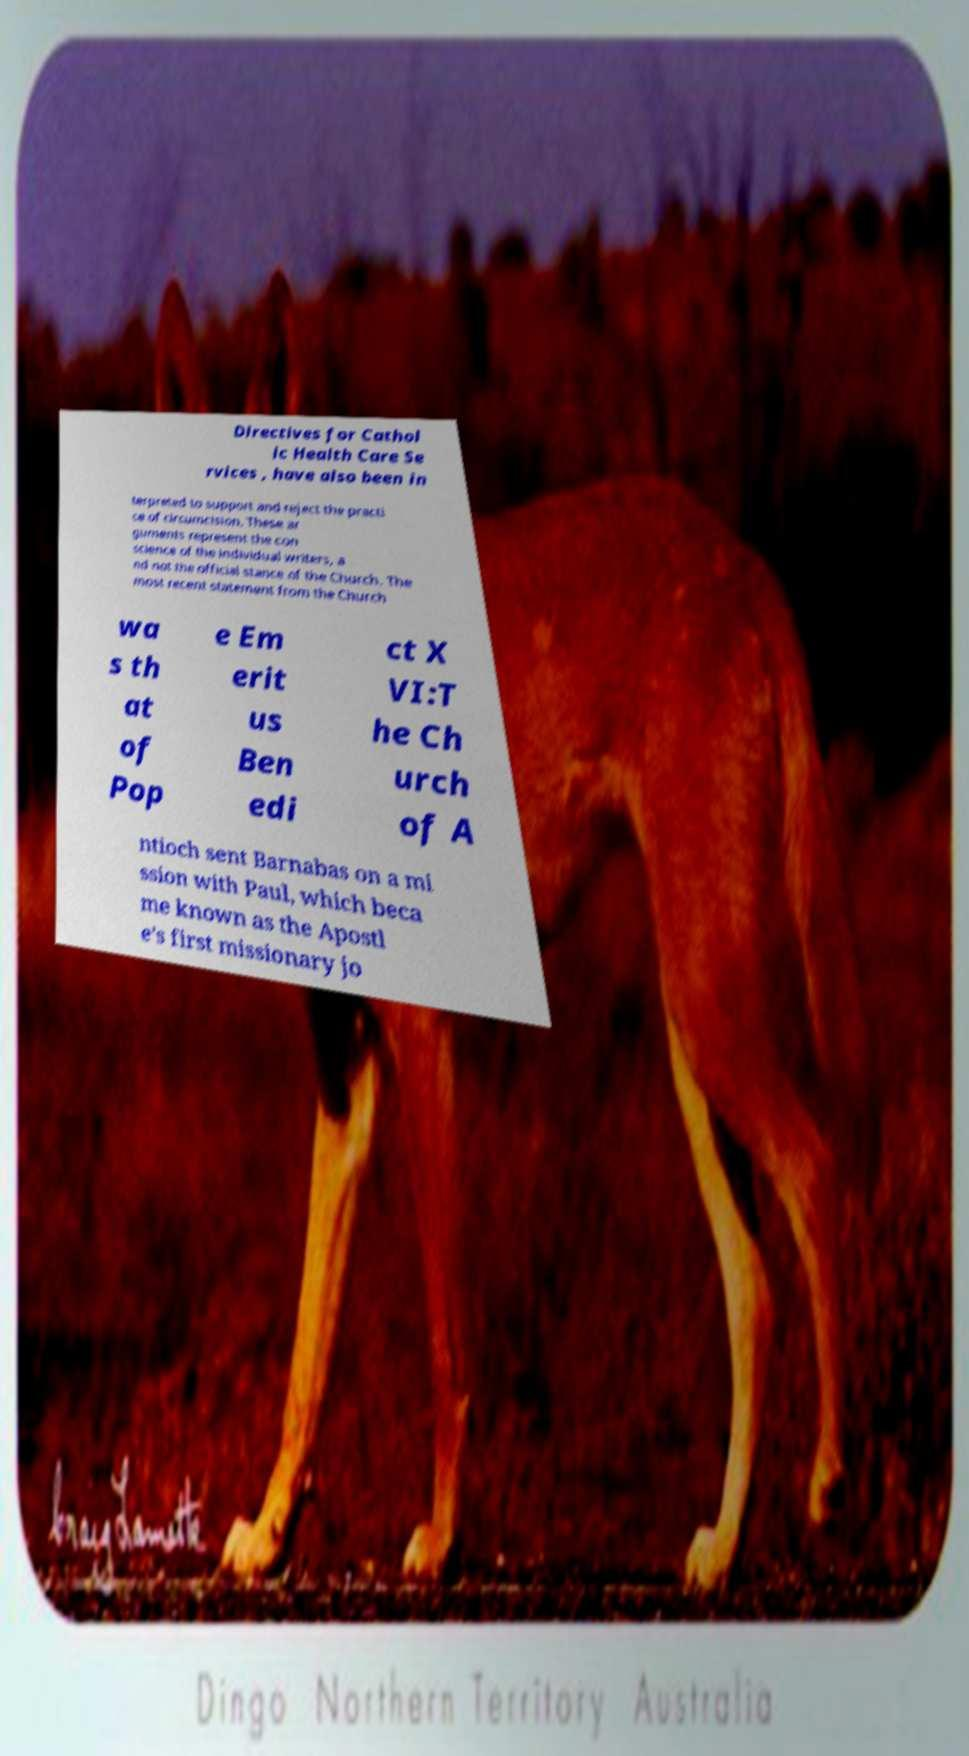Please read and relay the text visible in this image. What does it say? Directives for Cathol ic Health Care Se rvices , have also been in terpreted to support and reject the practi ce of circumcision. These ar guments represent the con science of the individual writers, a nd not the official stance of the Church. The most recent statement from the Church wa s th at of Pop e Em erit us Ben edi ct X VI:T he Ch urch of A ntioch sent Barnabas on a mi ssion with Paul, which beca me known as the Apostl e's first missionary jo 